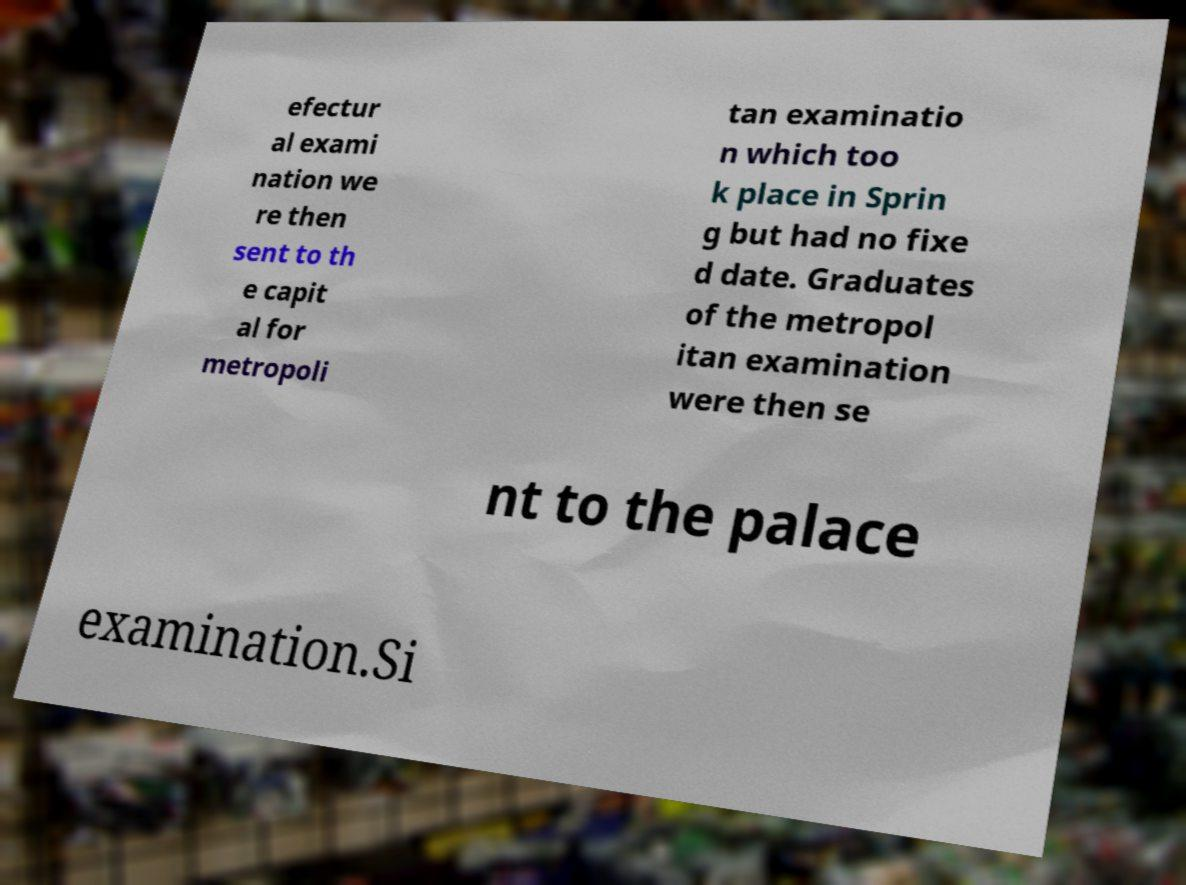Could you extract and type out the text from this image? efectur al exami nation we re then sent to th e capit al for metropoli tan examinatio n which too k place in Sprin g but had no fixe d date. Graduates of the metropol itan examination were then se nt to the palace examination.Si 